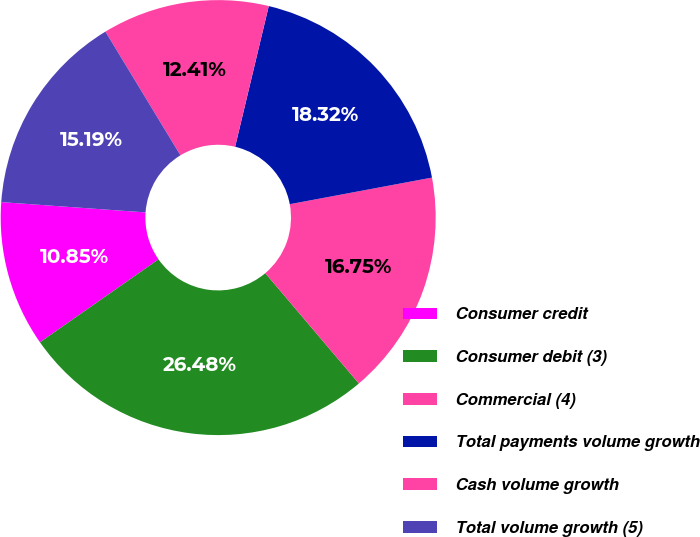Convert chart. <chart><loc_0><loc_0><loc_500><loc_500><pie_chart><fcel>Consumer credit<fcel>Consumer debit (3)<fcel>Commercial (4)<fcel>Total payments volume growth<fcel>Cash volume growth<fcel>Total volume growth (5)<nl><fcel>10.85%<fcel>26.48%<fcel>16.75%<fcel>18.32%<fcel>12.41%<fcel>15.19%<nl></chart> 